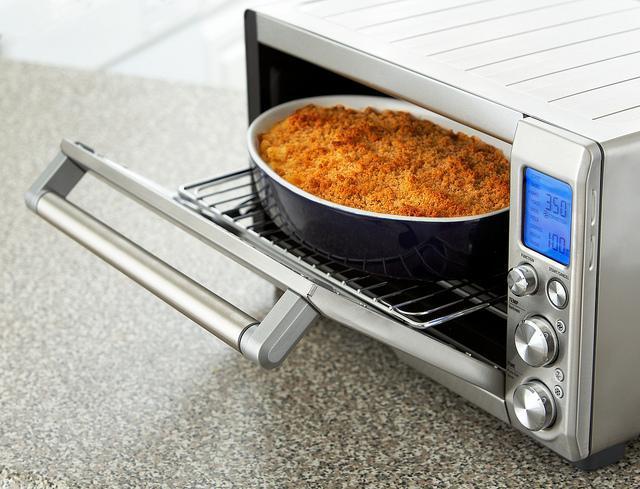How many people are wearing eyeglasses at the table?
Give a very brief answer. 0. 